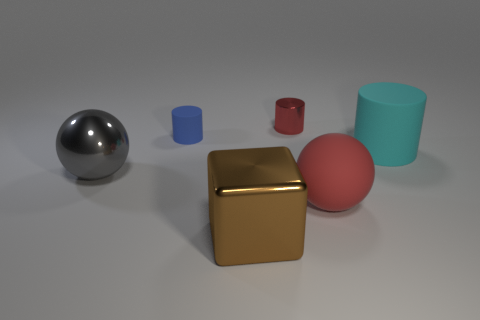Add 2 large gray shiny objects. How many objects exist? 8 Subtract all blocks. How many objects are left? 5 Subtract all cyan things. Subtract all cylinders. How many objects are left? 2 Add 5 tiny objects. How many tiny objects are left? 7 Add 5 cyan matte things. How many cyan matte things exist? 6 Subtract 1 cyan cylinders. How many objects are left? 5 